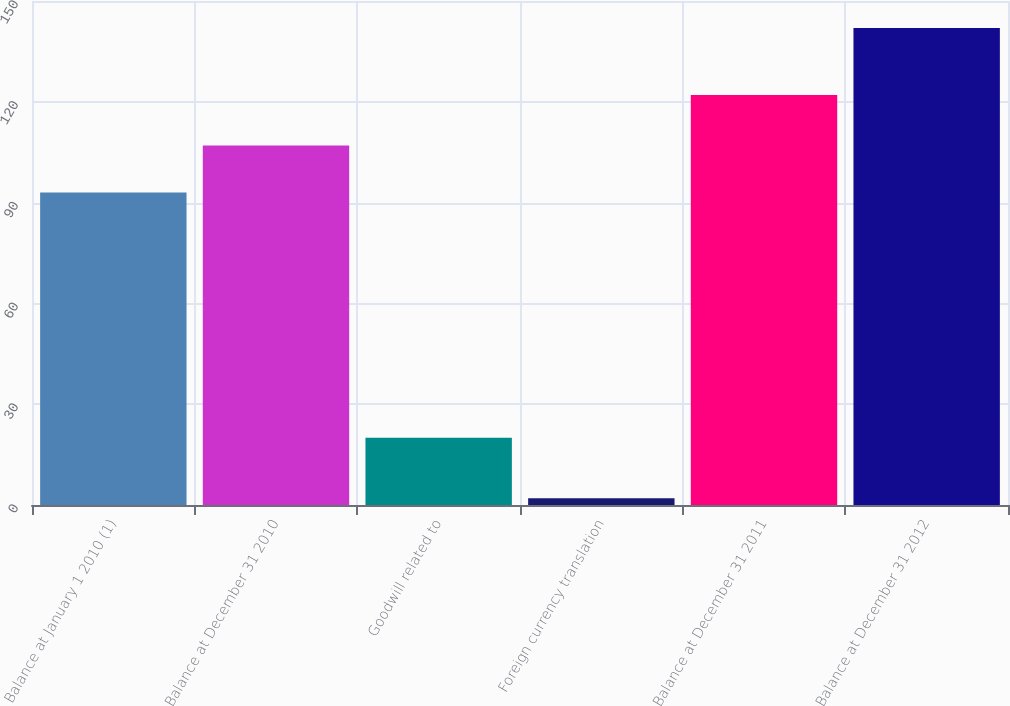Convert chart. <chart><loc_0><loc_0><loc_500><loc_500><bar_chart><fcel>Balance at January 1 2010 (1)<fcel>Balance at December 31 2010<fcel>Goodwill related to<fcel>Foreign currency translation<fcel>Balance at December 31 2011<fcel>Balance at December 31 2012<nl><fcel>93<fcel>107<fcel>20<fcel>2<fcel>122<fcel>142<nl></chart> 